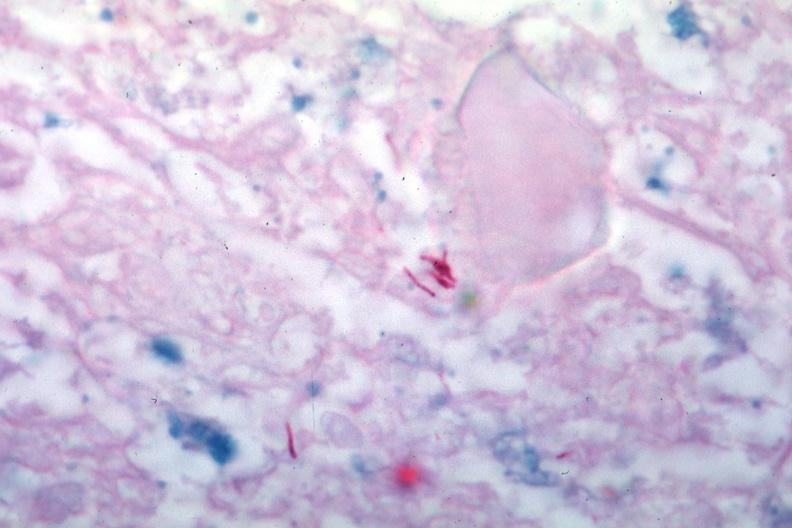what is present?
Answer the question using a single word or phrase. Tuberculosis 